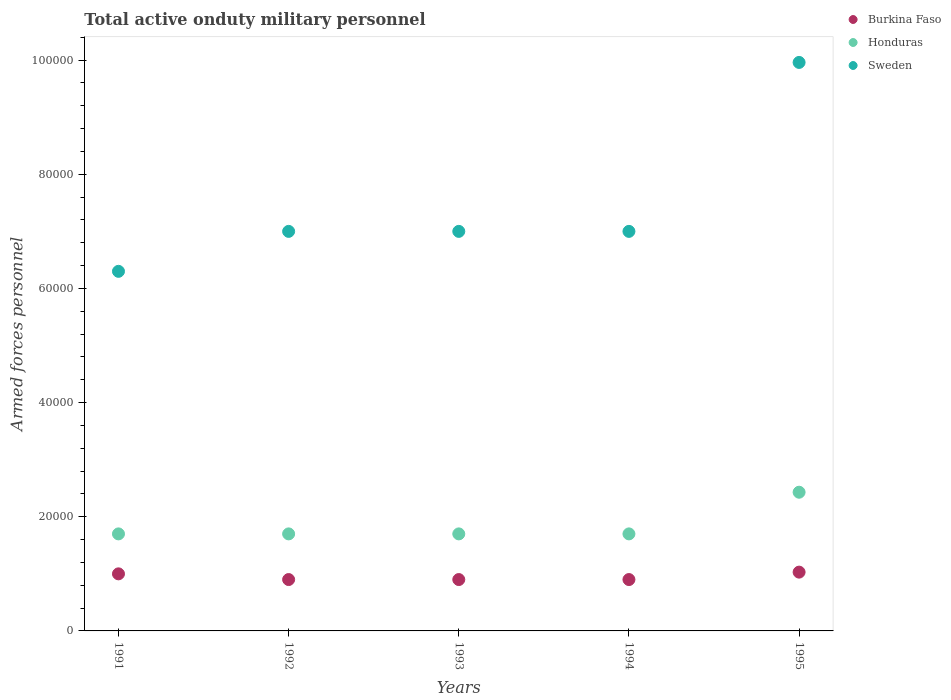How many different coloured dotlines are there?
Provide a short and direct response. 3. Is the number of dotlines equal to the number of legend labels?
Your answer should be very brief. Yes. What is the number of armed forces personnel in Sweden in 1994?
Provide a short and direct response. 7.00e+04. Across all years, what is the maximum number of armed forces personnel in Sweden?
Your response must be concise. 9.96e+04. Across all years, what is the minimum number of armed forces personnel in Sweden?
Make the answer very short. 6.30e+04. In which year was the number of armed forces personnel in Sweden maximum?
Keep it short and to the point. 1995. What is the total number of armed forces personnel in Sweden in the graph?
Your answer should be compact. 3.73e+05. What is the difference between the number of armed forces personnel in Burkina Faso in 1992 and that in 1994?
Provide a short and direct response. 0. What is the difference between the number of armed forces personnel in Sweden in 1994 and the number of armed forces personnel in Burkina Faso in 1995?
Provide a succinct answer. 5.97e+04. What is the average number of armed forces personnel in Sweden per year?
Provide a short and direct response. 7.45e+04. In the year 1992, what is the difference between the number of armed forces personnel in Sweden and number of armed forces personnel in Honduras?
Ensure brevity in your answer.  5.30e+04. What is the ratio of the number of armed forces personnel in Sweden in 1991 to that in 1994?
Offer a very short reply. 0.9. What is the difference between the highest and the second highest number of armed forces personnel in Honduras?
Provide a short and direct response. 7300. What is the difference between the highest and the lowest number of armed forces personnel in Honduras?
Offer a very short reply. 7300. Is it the case that in every year, the sum of the number of armed forces personnel in Sweden and number of armed forces personnel in Honduras  is greater than the number of armed forces personnel in Burkina Faso?
Offer a terse response. Yes. What is the difference between two consecutive major ticks on the Y-axis?
Give a very brief answer. 2.00e+04. Are the values on the major ticks of Y-axis written in scientific E-notation?
Make the answer very short. No. Does the graph contain any zero values?
Offer a very short reply. No. How are the legend labels stacked?
Your answer should be compact. Vertical. What is the title of the graph?
Make the answer very short. Total active onduty military personnel. What is the label or title of the X-axis?
Provide a succinct answer. Years. What is the label or title of the Y-axis?
Your response must be concise. Armed forces personnel. What is the Armed forces personnel of Burkina Faso in 1991?
Your answer should be compact. 10000. What is the Armed forces personnel in Honduras in 1991?
Offer a terse response. 1.70e+04. What is the Armed forces personnel of Sweden in 1991?
Make the answer very short. 6.30e+04. What is the Armed forces personnel of Burkina Faso in 1992?
Provide a succinct answer. 9000. What is the Armed forces personnel in Honduras in 1992?
Provide a succinct answer. 1.70e+04. What is the Armed forces personnel in Sweden in 1992?
Give a very brief answer. 7.00e+04. What is the Armed forces personnel in Burkina Faso in 1993?
Ensure brevity in your answer.  9000. What is the Armed forces personnel in Honduras in 1993?
Provide a succinct answer. 1.70e+04. What is the Armed forces personnel of Burkina Faso in 1994?
Offer a very short reply. 9000. What is the Armed forces personnel of Honduras in 1994?
Give a very brief answer. 1.70e+04. What is the Armed forces personnel of Burkina Faso in 1995?
Give a very brief answer. 1.03e+04. What is the Armed forces personnel of Honduras in 1995?
Your answer should be compact. 2.43e+04. What is the Armed forces personnel in Sweden in 1995?
Your response must be concise. 9.96e+04. Across all years, what is the maximum Armed forces personnel in Burkina Faso?
Offer a very short reply. 1.03e+04. Across all years, what is the maximum Armed forces personnel of Honduras?
Provide a succinct answer. 2.43e+04. Across all years, what is the maximum Armed forces personnel of Sweden?
Your answer should be compact. 9.96e+04. Across all years, what is the minimum Armed forces personnel of Burkina Faso?
Offer a terse response. 9000. Across all years, what is the minimum Armed forces personnel of Honduras?
Keep it short and to the point. 1.70e+04. Across all years, what is the minimum Armed forces personnel of Sweden?
Make the answer very short. 6.30e+04. What is the total Armed forces personnel of Burkina Faso in the graph?
Your answer should be compact. 4.73e+04. What is the total Armed forces personnel in Honduras in the graph?
Provide a short and direct response. 9.23e+04. What is the total Armed forces personnel of Sweden in the graph?
Make the answer very short. 3.73e+05. What is the difference between the Armed forces personnel in Burkina Faso in 1991 and that in 1992?
Make the answer very short. 1000. What is the difference between the Armed forces personnel in Sweden in 1991 and that in 1992?
Offer a very short reply. -7000. What is the difference between the Armed forces personnel in Burkina Faso in 1991 and that in 1993?
Make the answer very short. 1000. What is the difference between the Armed forces personnel in Sweden in 1991 and that in 1993?
Offer a very short reply. -7000. What is the difference between the Armed forces personnel of Sweden in 1991 and that in 1994?
Ensure brevity in your answer.  -7000. What is the difference between the Armed forces personnel in Burkina Faso in 1991 and that in 1995?
Give a very brief answer. -300. What is the difference between the Armed forces personnel of Honduras in 1991 and that in 1995?
Your answer should be compact. -7300. What is the difference between the Armed forces personnel in Sweden in 1991 and that in 1995?
Your answer should be compact. -3.66e+04. What is the difference between the Armed forces personnel in Burkina Faso in 1992 and that in 1993?
Keep it short and to the point. 0. What is the difference between the Armed forces personnel of Honduras in 1992 and that in 1993?
Ensure brevity in your answer.  0. What is the difference between the Armed forces personnel in Sweden in 1992 and that in 1993?
Keep it short and to the point. 0. What is the difference between the Armed forces personnel in Honduras in 1992 and that in 1994?
Offer a terse response. 0. What is the difference between the Armed forces personnel of Sweden in 1992 and that in 1994?
Provide a short and direct response. 0. What is the difference between the Armed forces personnel of Burkina Faso in 1992 and that in 1995?
Your answer should be compact. -1300. What is the difference between the Armed forces personnel in Honduras in 1992 and that in 1995?
Your response must be concise. -7300. What is the difference between the Armed forces personnel in Sweden in 1992 and that in 1995?
Offer a terse response. -2.96e+04. What is the difference between the Armed forces personnel in Burkina Faso in 1993 and that in 1995?
Your answer should be compact. -1300. What is the difference between the Armed forces personnel of Honduras in 1993 and that in 1995?
Provide a short and direct response. -7300. What is the difference between the Armed forces personnel in Sweden in 1993 and that in 1995?
Give a very brief answer. -2.96e+04. What is the difference between the Armed forces personnel in Burkina Faso in 1994 and that in 1995?
Your answer should be compact. -1300. What is the difference between the Armed forces personnel of Honduras in 1994 and that in 1995?
Your answer should be very brief. -7300. What is the difference between the Armed forces personnel in Sweden in 1994 and that in 1995?
Offer a terse response. -2.96e+04. What is the difference between the Armed forces personnel of Burkina Faso in 1991 and the Armed forces personnel of Honduras in 1992?
Give a very brief answer. -7000. What is the difference between the Armed forces personnel in Honduras in 1991 and the Armed forces personnel in Sweden in 1992?
Make the answer very short. -5.30e+04. What is the difference between the Armed forces personnel in Burkina Faso in 1991 and the Armed forces personnel in Honduras in 1993?
Your answer should be very brief. -7000. What is the difference between the Armed forces personnel in Burkina Faso in 1991 and the Armed forces personnel in Sweden in 1993?
Your answer should be very brief. -6.00e+04. What is the difference between the Armed forces personnel in Honduras in 1991 and the Armed forces personnel in Sweden in 1993?
Provide a short and direct response. -5.30e+04. What is the difference between the Armed forces personnel in Burkina Faso in 1991 and the Armed forces personnel in Honduras in 1994?
Your response must be concise. -7000. What is the difference between the Armed forces personnel in Honduras in 1991 and the Armed forces personnel in Sweden in 1994?
Provide a succinct answer. -5.30e+04. What is the difference between the Armed forces personnel of Burkina Faso in 1991 and the Armed forces personnel of Honduras in 1995?
Your answer should be compact. -1.43e+04. What is the difference between the Armed forces personnel in Burkina Faso in 1991 and the Armed forces personnel in Sweden in 1995?
Your answer should be very brief. -8.96e+04. What is the difference between the Armed forces personnel in Honduras in 1991 and the Armed forces personnel in Sweden in 1995?
Your answer should be very brief. -8.26e+04. What is the difference between the Armed forces personnel in Burkina Faso in 1992 and the Armed forces personnel in Honduras in 1993?
Provide a succinct answer. -8000. What is the difference between the Armed forces personnel of Burkina Faso in 1992 and the Armed forces personnel of Sweden in 1993?
Offer a very short reply. -6.10e+04. What is the difference between the Armed forces personnel in Honduras in 1992 and the Armed forces personnel in Sweden in 1993?
Keep it short and to the point. -5.30e+04. What is the difference between the Armed forces personnel of Burkina Faso in 1992 and the Armed forces personnel of Honduras in 1994?
Provide a short and direct response. -8000. What is the difference between the Armed forces personnel of Burkina Faso in 1992 and the Armed forces personnel of Sweden in 1994?
Your response must be concise. -6.10e+04. What is the difference between the Armed forces personnel in Honduras in 1992 and the Armed forces personnel in Sweden in 1994?
Your answer should be compact. -5.30e+04. What is the difference between the Armed forces personnel in Burkina Faso in 1992 and the Armed forces personnel in Honduras in 1995?
Give a very brief answer. -1.53e+04. What is the difference between the Armed forces personnel of Burkina Faso in 1992 and the Armed forces personnel of Sweden in 1995?
Provide a succinct answer. -9.06e+04. What is the difference between the Armed forces personnel of Honduras in 1992 and the Armed forces personnel of Sweden in 1995?
Provide a short and direct response. -8.26e+04. What is the difference between the Armed forces personnel of Burkina Faso in 1993 and the Armed forces personnel of Honduras in 1994?
Provide a short and direct response. -8000. What is the difference between the Armed forces personnel of Burkina Faso in 1993 and the Armed forces personnel of Sweden in 1994?
Ensure brevity in your answer.  -6.10e+04. What is the difference between the Armed forces personnel in Honduras in 1993 and the Armed forces personnel in Sweden in 1994?
Offer a terse response. -5.30e+04. What is the difference between the Armed forces personnel in Burkina Faso in 1993 and the Armed forces personnel in Honduras in 1995?
Provide a succinct answer. -1.53e+04. What is the difference between the Armed forces personnel in Burkina Faso in 1993 and the Armed forces personnel in Sweden in 1995?
Give a very brief answer. -9.06e+04. What is the difference between the Armed forces personnel of Honduras in 1993 and the Armed forces personnel of Sweden in 1995?
Keep it short and to the point. -8.26e+04. What is the difference between the Armed forces personnel of Burkina Faso in 1994 and the Armed forces personnel of Honduras in 1995?
Your answer should be very brief. -1.53e+04. What is the difference between the Armed forces personnel of Burkina Faso in 1994 and the Armed forces personnel of Sweden in 1995?
Offer a terse response. -9.06e+04. What is the difference between the Armed forces personnel in Honduras in 1994 and the Armed forces personnel in Sweden in 1995?
Your answer should be very brief. -8.26e+04. What is the average Armed forces personnel in Burkina Faso per year?
Provide a succinct answer. 9460. What is the average Armed forces personnel in Honduras per year?
Your answer should be compact. 1.85e+04. What is the average Armed forces personnel in Sweden per year?
Your answer should be compact. 7.45e+04. In the year 1991, what is the difference between the Armed forces personnel of Burkina Faso and Armed forces personnel of Honduras?
Your answer should be very brief. -7000. In the year 1991, what is the difference between the Armed forces personnel of Burkina Faso and Armed forces personnel of Sweden?
Your answer should be very brief. -5.30e+04. In the year 1991, what is the difference between the Armed forces personnel of Honduras and Armed forces personnel of Sweden?
Give a very brief answer. -4.60e+04. In the year 1992, what is the difference between the Armed forces personnel of Burkina Faso and Armed forces personnel of Honduras?
Provide a succinct answer. -8000. In the year 1992, what is the difference between the Armed forces personnel of Burkina Faso and Armed forces personnel of Sweden?
Your response must be concise. -6.10e+04. In the year 1992, what is the difference between the Armed forces personnel in Honduras and Armed forces personnel in Sweden?
Keep it short and to the point. -5.30e+04. In the year 1993, what is the difference between the Armed forces personnel in Burkina Faso and Armed forces personnel in Honduras?
Offer a terse response. -8000. In the year 1993, what is the difference between the Armed forces personnel in Burkina Faso and Armed forces personnel in Sweden?
Make the answer very short. -6.10e+04. In the year 1993, what is the difference between the Armed forces personnel in Honduras and Armed forces personnel in Sweden?
Your response must be concise. -5.30e+04. In the year 1994, what is the difference between the Armed forces personnel of Burkina Faso and Armed forces personnel of Honduras?
Your answer should be very brief. -8000. In the year 1994, what is the difference between the Armed forces personnel of Burkina Faso and Armed forces personnel of Sweden?
Make the answer very short. -6.10e+04. In the year 1994, what is the difference between the Armed forces personnel of Honduras and Armed forces personnel of Sweden?
Give a very brief answer. -5.30e+04. In the year 1995, what is the difference between the Armed forces personnel of Burkina Faso and Armed forces personnel of Honduras?
Keep it short and to the point. -1.40e+04. In the year 1995, what is the difference between the Armed forces personnel in Burkina Faso and Armed forces personnel in Sweden?
Ensure brevity in your answer.  -8.93e+04. In the year 1995, what is the difference between the Armed forces personnel in Honduras and Armed forces personnel in Sweden?
Your answer should be very brief. -7.53e+04. What is the ratio of the Armed forces personnel in Burkina Faso in 1991 to that in 1992?
Offer a very short reply. 1.11. What is the ratio of the Armed forces personnel in Honduras in 1991 to that in 1992?
Offer a terse response. 1. What is the ratio of the Armed forces personnel in Honduras in 1991 to that in 1993?
Your response must be concise. 1. What is the ratio of the Armed forces personnel of Sweden in 1991 to that in 1993?
Give a very brief answer. 0.9. What is the ratio of the Armed forces personnel in Honduras in 1991 to that in 1994?
Keep it short and to the point. 1. What is the ratio of the Armed forces personnel in Burkina Faso in 1991 to that in 1995?
Your answer should be compact. 0.97. What is the ratio of the Armed forces personnel in Honduras in 1991 to that in 1995?
Offer a very short reply. 0.7. What is the ratio of the Armed forces personnel in Sweden in 1991 to that in 1995?
Your answer should be compact. 0.63. What is the ratio of the Armed forces personnel of Honduras in 1992 to that in 1993?
Provide a short and direct response. 1. What is the ratio of the Armed forces personnel of Burkina Faso in 1992 to that in 1994?
Keep it short and to the point. 1. What is the ratio of the Armed forces personnel in Burkina Faso in 1992 to that in 1995?
Your answer should be very brief. 0.87. What is the ratio of the Armed forces personnel of Honduras in 1992 to that in 1995?
Make the answer very short. 0.7. What is the ratio of the Armed forces personnel of Sweden in 1992 to that in 1995?
Ensure brevity in your answer.  0.7. What is the ratio of the Armed forces personnel of Honduras in 1993 to that in 1994?
Your response must be concise. 1. What is the ratio of the Armed forces personnel in Burkina Faso in 1993 to that in 1995?
Make the answer very short. 0.87. What is the ratio of the Armed forces personnel of Honduras in 1993 to that in 1995?
Provide a succinct answer. 0.7. What is the ratio of the Armed forces personnel of Sweden in 1993 to that in 1995?
Your answer should be very brief. 0.7. What is the ratio of the Armed forces personnel of Burkina Faso in 1994 to that in 1995?
Give a very brief answer. 0.87. What is the ratio of the Armed forces personnel of Honduras in 1994 to that in 1995?
Offer a very short reply. 0.7. What is the ratio of the Armed forces personnel of Sweden in 1994 to that in 1995?
Give a very brief answer. 0.7. What is the difference between the highest and the second highest Armed forces personnel of Burkina Faso?
Provide a short and direct response. 300. What is the difference between the highest and the second highest Armed forces personnel of Honduras?
Offer a terse response. 7300. What is the difference between the highest and the second highest Armed forces personnel in Sweden?
Your response must be concise. 2.96e+04. What is the difference between the highest and the lowest Armed forces personnel of Burkina Faso?
Offer a very short reply. 1300. What is the difference between the highest and the lowest Armed forces personnel of Honduras?
Offer a terse response. 7300. What is the difference between the highest and the lowest Armed forces personnel in Sweden?
Your answer should be compact. 3.66e+04. 